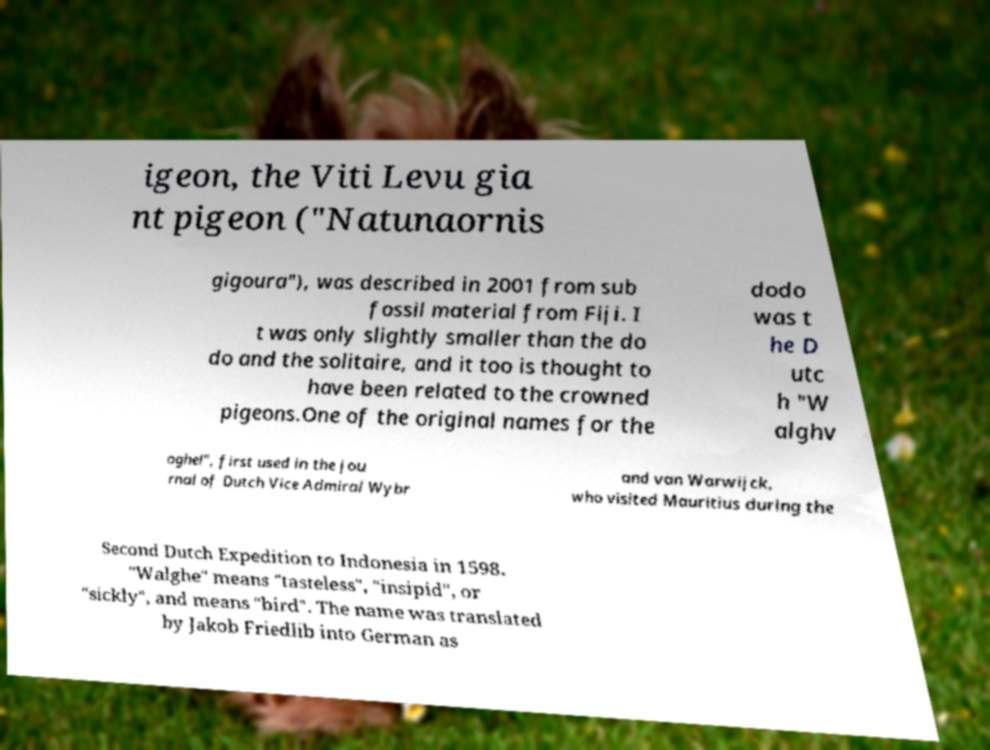Could you extract and type out the text from this image? igeon, the Viti Levu gia nt pigeon ("Natunaornis gigoura"), was described in 2001 from sub fossil material from Fiji. I t was only slightly smaller than the do do and the solitaire, and it too is thought to have been related to the crowned pigeons.One of the original names for the dodo was t he D utc h "W alghv oghel", first used in the jou rnal of Dutch Vice Admiral Wybr and van Warwijck, who visited Mauritius during the Second Dutch Expedition to Indonesia in 1598. "Walghe" means "tasteless", "insipid", or "sickly", and means "bird". The name was translated by Jakob Friedlib into German as 